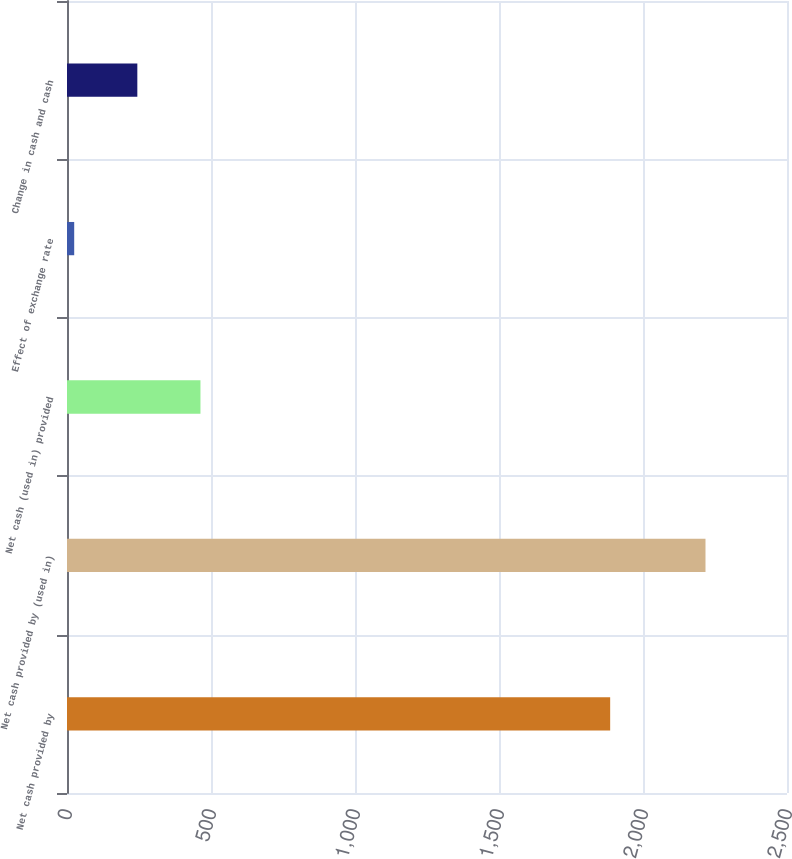Convert chart to OTSL. <chart><loc_0><loc_0><loc_500><loc_500><bar_chart><fcel>Net cash provided by<fcel>Net cash provided by (used in)<fcel>Net cash (used in) provided<fcel>Effect of exchange rate<fcel>Change in cash and cash<nl><fcel>1886<fcel>2217<fcel>463.4<fcel>25<fcel>244.2<nl></chart> 